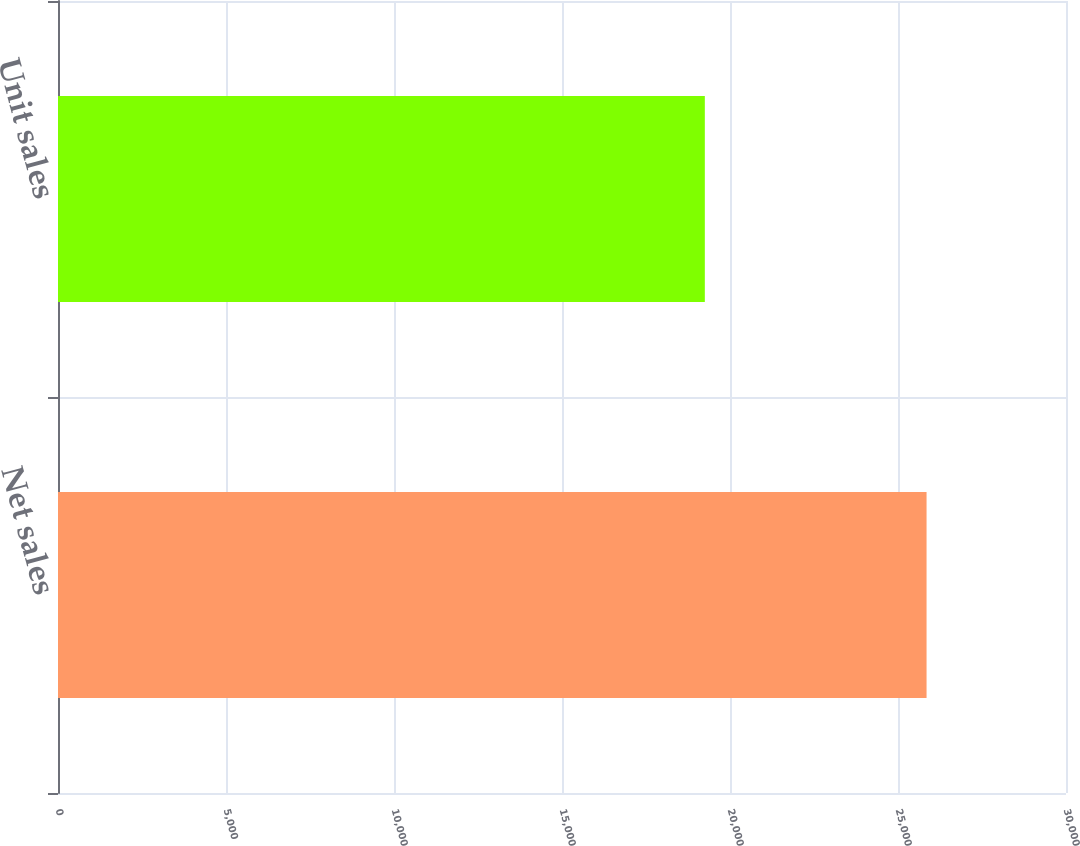Convert chart. <chart><loc_0><loc_0><loc_500><loc_500><bar_chart><fcel>Net sales<fcel>Unit sales<nl><fcel>25850<fcel>19251<nl></chart> 